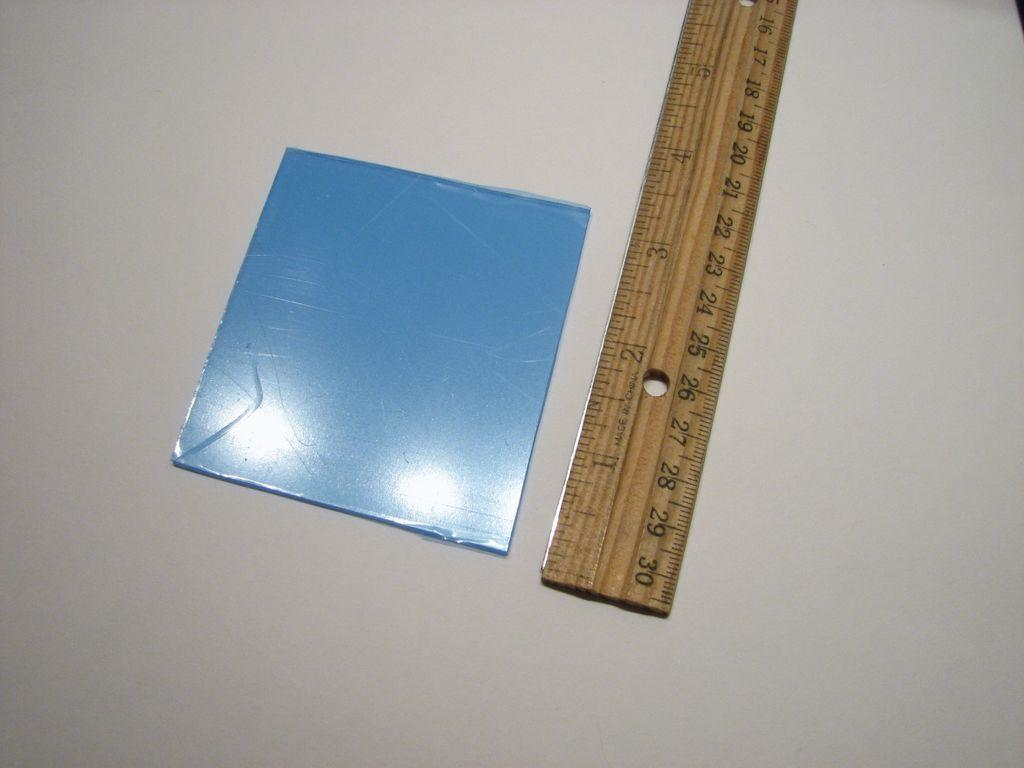<image>
Offer a succinct explanation of the picture presented. a ruler laying on the table ends at 30 